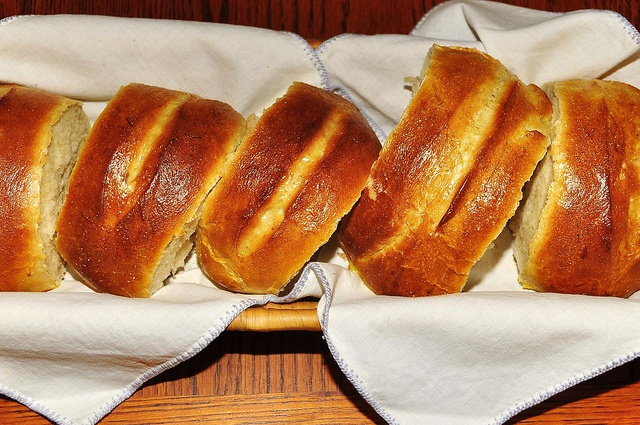Describe the objects in this image and their specific colors. I can see hot dog in maroon, brown, and red tones, hot dog in maroon, red, and brown tones, and hot dog in maroon, brown, tan, and orange tones in this image. 